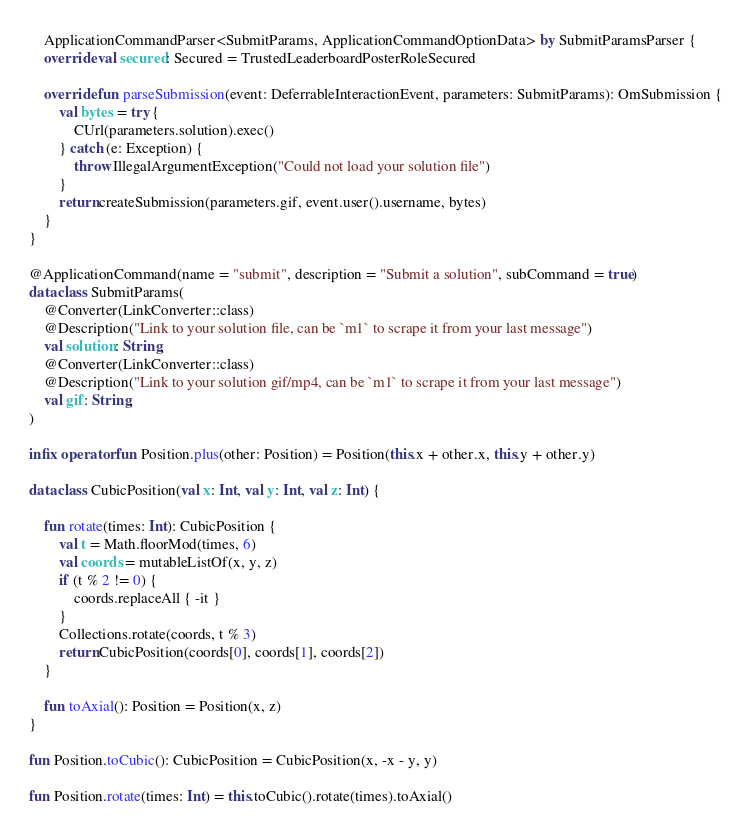<code> <loc_0><loc_0><loc_500><loc_500><_Kotlin_>    ApplicationCommandParser<SubmitParams, ApplicationCommandOptionData> by SubmitParamsParser {
    override val secured: Secured = TrustedLeaderboardPosterRoleSecured

    override fun parseSubmission(event: DeferrableInteractionEvent, parameters: SubmitParams): OmSubmission {
        val bytes = try {
            CUrl(parameters.solution).exec()
        } catch (e: Exception) {
            throw IllegalArgumentException("Could not load your solution file")
        }
        return createSubmission(parameters.gif, event.user().username, bytes)
    }
}

@ApplicationCommand(name = "submit", description = "Submit a solution", subCommand = true)
data class SubmitParams(
    @Converter(LinkConverter::class)
    @Description("Link to your solution file, can be `m1` to scrape it from your last message")
    val solution: String,
    @Converter(LinkConverter::class)
    @Description("Link to your solution gif/mp4, can be `m1` to scrape it from your last message")
    val gif: String,
)

infix operator fun Position.plus(other: Position) = Position(this.x + other.x, this.y + other.y)

data class CubicPosition(val x: Int, val y: Int, val z: Int) {

    fun rotate(times: Int): CubicPosition {
        val t = Math.floorMod(times, 6)
        val coords = mutableListOf(x, y, z)
        if (t % 2 != 0) {
            coords.replaceAll { -it }
        }
        Collections.rotate(coords, t % 3)
        return CubicPosition(coords[0], coords[1], coords[2])
    }

    fun toAxial(): Position = Position(x, z)
}

fun Position.toCubic(): CubicPosition = CubicPosition(x, -x - y, y)

fun Position.rotate(times: Int) = this.toCubic().rotate(times).toAxial()</code> 